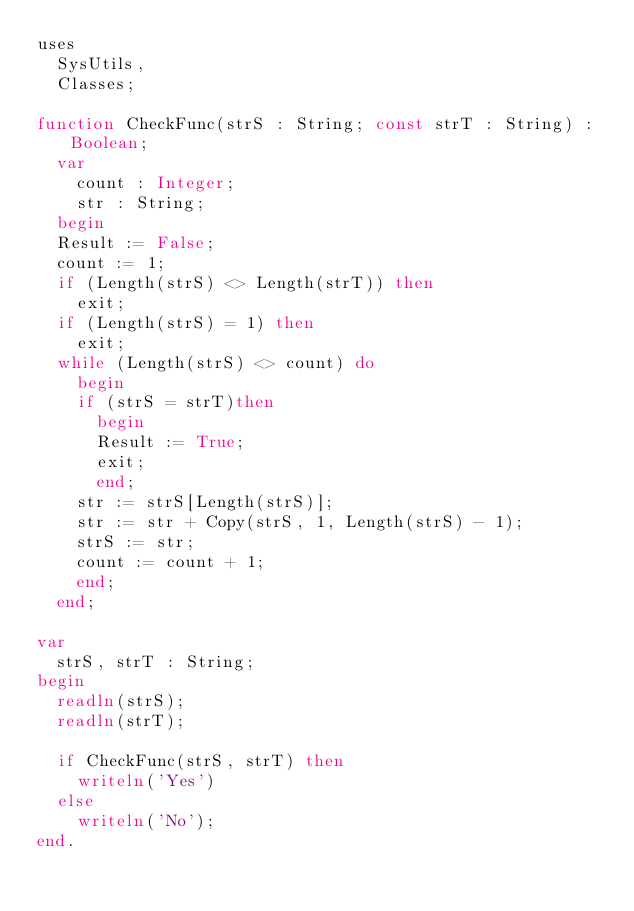<code> <loc_0><loc_0><loc_500><loc_500><_Pascal_>uses
  SysUtils,
  Classes;
  
function CheckFunc(strS : String; const strT : String) : Boolean;
	var
		count : Integer;
		str : String;
	begin
	Result := False;
	count := 1;
	if (Length(strS) <> Length(strT)) then
		exit;
	if (Length(strS) = 1) then
		exit;
	while (Length(strS) <> count) do
		begin
		if (strS = strT)then
			begin
			Result := True;
			exit;
			end;
		str := strS[Length(strS)];
		str := str + Copy(strS, 1, Length(strS) - 1);
		strS := str;
		count := count + 1;
		end;
	end;

var
	strS, strT : String;
begin	
	readln(strS);
	readln(strT);
	
	if CheckFunc(strS, strT) then
		writeln('Yes')
	else
		writeln('No');
end.</code> 